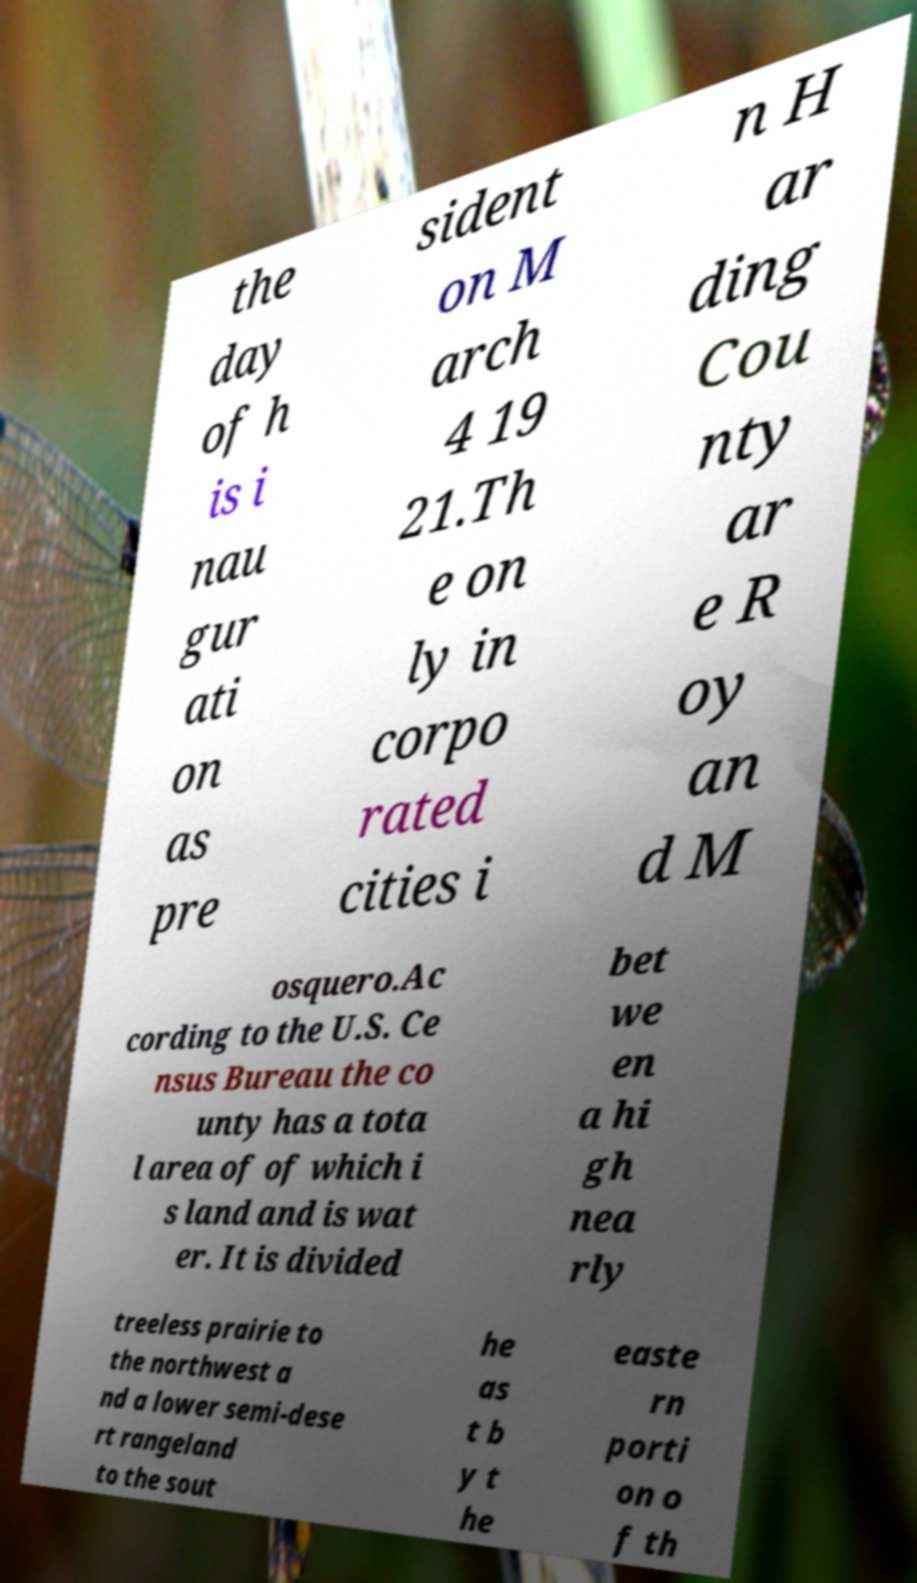Can you accurately transcribe the text from the provided image for me? the day of h is i nau gur ati on as pre sident on M arch 4 19 21.Th e on ly in corpo rated cities i n H ar ding Cou nty ar e R oy an d M osquero.Ac cording to the U.S. Ce nsus Bureau the co unty has a tota l area of of which i s land and is wat er. It is divided bet we en a hi gh nea rly treeless prairie to the northwest a nd a lower semi-dese rt rangeland to the sout he as t b y t he easte rn porti on o f th 